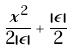<formula> <loc_0><loc_0><loc_500><loc_500>\frac { x ^ { 2 } } { 2 | \epsilon | } + \frac { | \epsilon | } { 2 }</formula> 